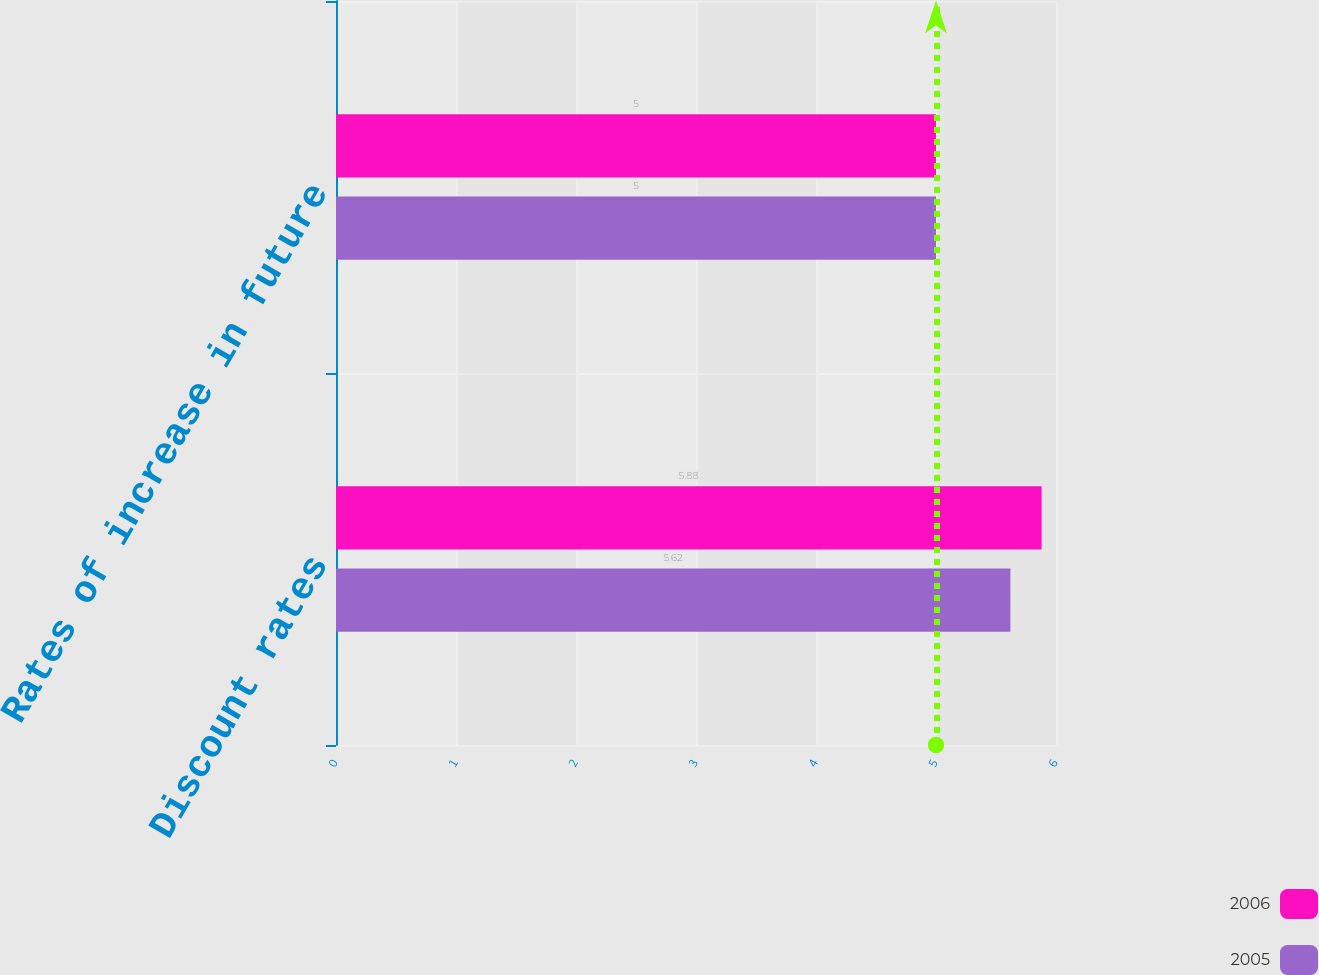Convert chart. <chart><loc_0><loc_0><loc_500><loc_500><stacked_bar_chart><ecel><fcel>Discount rates<fcel>Rates of increase in future<nl><fcel>2006<fcel>5.88<fcel>5<nl><fcel>2005<fcel>5.62<fcel>5<nl></chart> 